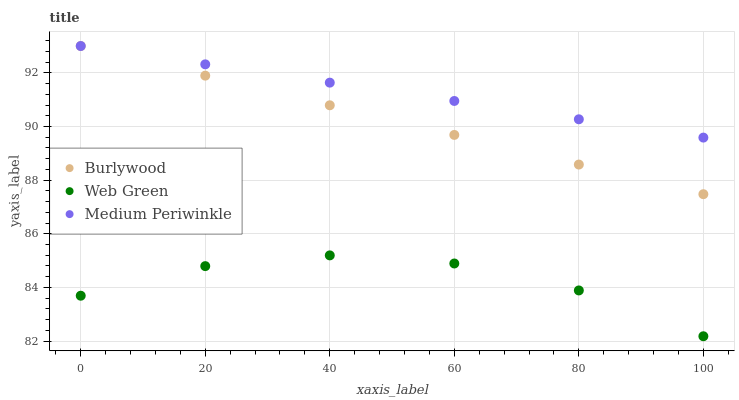Does Web Green have the minimum area under the curve?
Answer yes or no. Yes. Does Medium Periwinkle have the maximum area under the curve?
Answer yes or no. Yes. Does Medium Periwinkle have the minimum area under the curve?
Answer yes or no. No. Does Web Green have the maximum area under the curve?
Answer yes or no. No. Is Burlywood the smoothest?
Answer yes or no. Yes. Is Web Green the roughest?
Answer yes or no. Yes. Is Medium Periwinkle the smoothest?
Answer yes or no. No. Is Medium Periwinkle the roughest?
Answer yes or no. No. Does Web Green have the lowest value?
Answer yes or no. Yes. Does Medium Periwinkle have the lowest value?
Answer yes or no. No. Does Medium Periwinkle have the highest value?
Answer yes or no. Yes. Does Web Green have the highest value?
Answer yes or no. No. Is Web Green less than Medium Periwinkle?
Answer yes or no. Yes. Is Medium Periwinkle greater than Web Green?
Answer yes or no. Yes. Does Medium Periwinkle intersect Burlywood?
Answer yes or no. Yes. Is Medium Periwinkle less than Burlywood?
Answer yes or no. No. Is Medium Periwinkle greater than Burlywood?
Answer yes or no. No. Does Web Green intersect Medium Periwinkle?
Answer yes or no. No. 